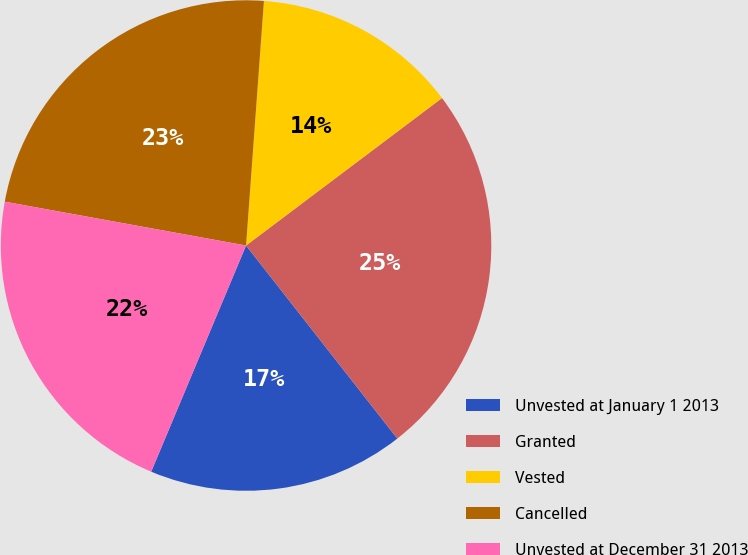Convert chart to OTSL. <chart><loc_0><loc_0><loc_500><loc_500><pie_chart><fcel>Unvested at January 1 2013<fcel>Granted<fcel>Vested<fcel>Cancelled<fcel>Unvested at December 31 2013<nl><fcel>16.9%<fcel>24.69%<fcel>13.57%<fcel>23.3%<fcel>21.54%<nl></chart> 